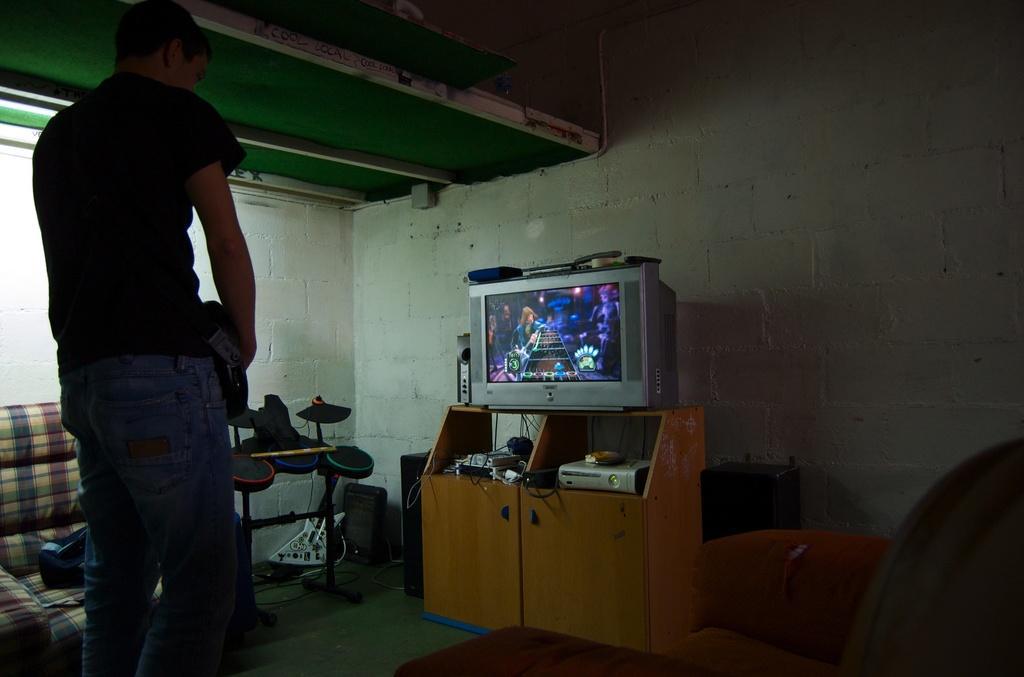Can you describe this image briefly? In this picture we can see a man is standing on the path and in front of the man there is a television, cables and other things. Behind the television, there is a wall and on the left side of the man there is a chair and other things. 